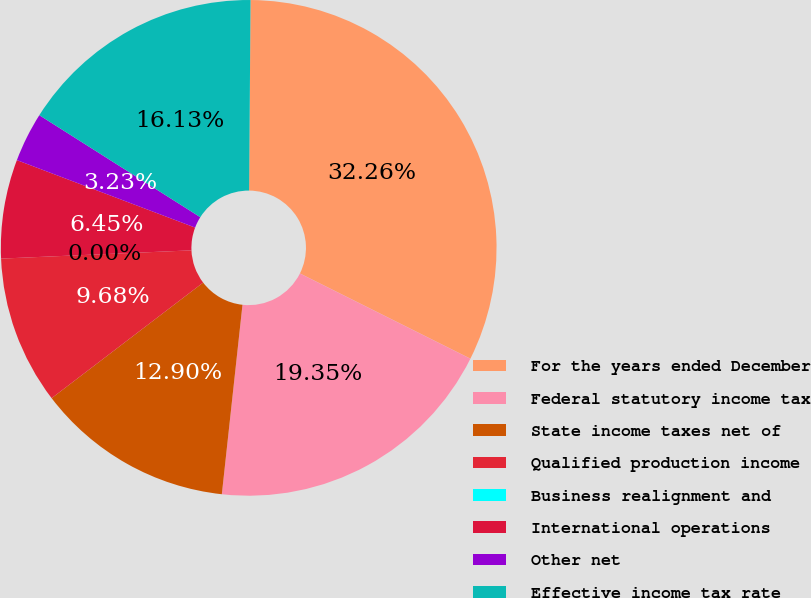Convert chart to OTSL. <chart><loc_0><loc_0><loc_500><loc_500><pie_chart><fcel>For the years ended December<fcel>Federal statutory income tax<fcel>State income taxes net of<fcel>Qualified production income<fcel>Business realignment and<fcel>International operations<fcel>Other net<fcel>Effective income tax rate<nl><fcel>32.26%<fcel>19.35%<fcel>12.9%<fcel>9.68%<fcel>0.0%<fcel>6.45%<fcel>3.23%<fcel>16.13%<nl></chart> 